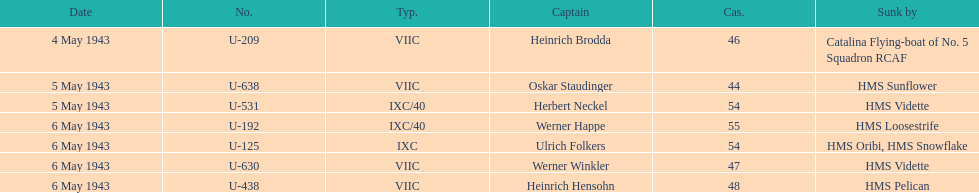Could you parse the entire table as a dict? {'header': ['Date', 'No.', 'Typ.', 'Captain', 'Cas.', 'Sunk by'], 'rows': [['4 May 1943', 'U-209', 'VIIC', 'Heinrich Brodda', '46', 'Catalina Flying-boat of No. 5 Squadron RCAF'], ['5 May 1943', 'U-638', 'VIIC', 'Oskar Staudinger', '44', 'HMS Sunflower'], ['5 May 1943', 'U-531', 'IXC/40', 'Herbert Neckel', '54', 'HMS Vidette'], ['6 May 1943', 'U-192', 'IXC/40', 'Werner Happe', '55', 'HMS Loosestrife'], ['6 May 1943', 'U-125', 'IXC', 'Ulrich Folkers', '54', 'HMS Oribi, HMS Snowflake'], ['6 May 1943', 'U-630', 'VIIC', 'Werner Winkler', '47', 'HMS Vidette'], ['6 May 1943', 'U-438', 'VIIC', 'Heinrich Hensohn', '48', 'HMS Pelican']]} Which ship was responsible for sinking the most submarines? HMS Vidette. 